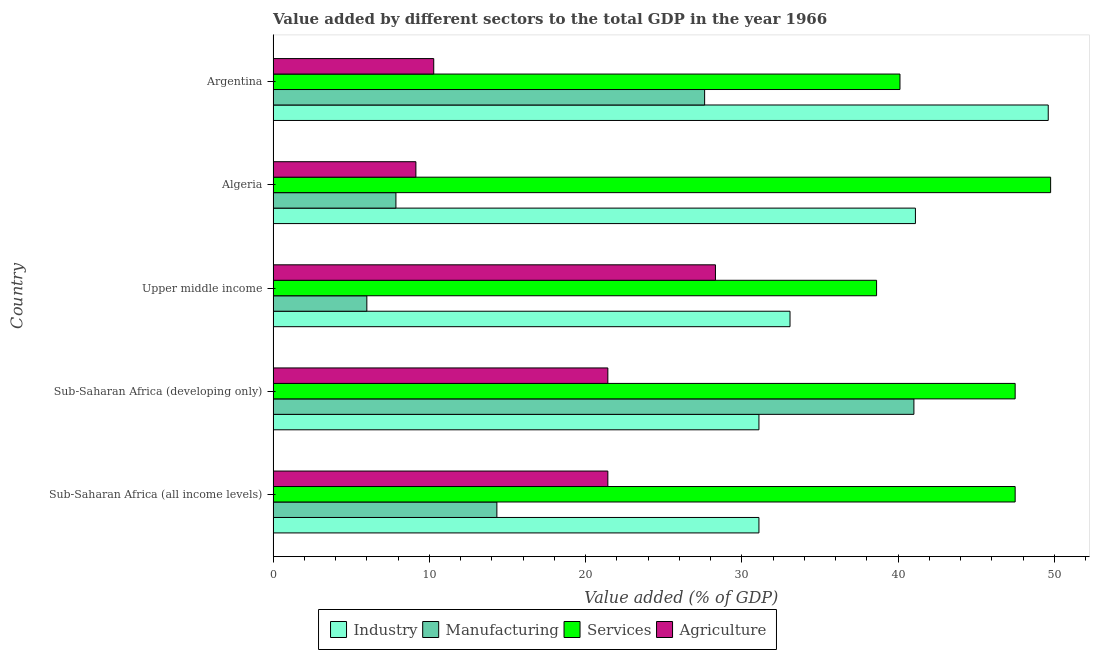How many different coloured bars are there?
Provide a short and direct response. 4. Are the number of bars per tick equal to the number of legend labels?
Ensure brevity in your answer.  Yes. Are the number of bars on each tick of the Y-axis equal?
Your response must be concise. Yes. How many bars are there on the 5th tick from the top?
Give a very brief answer. 4. What is the label of the 5th group of bars from the top?
Keep it short and to the point. Sub-Saharan Africa (all income levels). In how many cases, is the number of bars for a given country not equal to the number of legend labels?
Offer a very short reply. 0. What is the value added by manufacturing sector in Upper middle income?
Provide a short and direct response. 6. Across all countries, what is the maximum value added by industrial sector?
Make the answer very short. 49.6. Across all countries, what is the minimum value added by manufacturing sector?
Give a very brief answer. 6. In which country was the value added by services sector maximum?
Your answer should be compact. Algeria. In which country was the value added by industrial sector minimum?
Make the answer very short. Sub-Saharan Africa (all income levels). What is the total value added by industrial sector in the graph?
Your answer should be compact. 185.97. What is the difference between the value added by manufacturing sector in Algeria and that in Sub-Saharan Africa (all income levels)?
Offer a terse response. -6.46. What is the difference between the value added by services sector in Sub-Saharan Africa (developing only) and the value added by agricultural sector in Algeria?
Offer a terse response. 38.35. What is the average value added by industrial sector per country?
Ensure brevity in your answer.  37.19. What is the difference between the value added by services sector and value added by agricultural sector in Sub-Saharan Africa (all income levels)?
Provide a short and direct response. 26.07. What is the ratio of the value added by agricultural sector in Algeria to that in Argentina?
Your answer should be compact. 0.89. Is the value added by agricultural sector in Sub-Saharan Africa (all income levels) less than that in Sub-Saharan Africa (developing only)?
Your response must be concise. No. Is the difference between the value added by industrial sector in Algeria and Sub-Saharan Africa (developing only) greater than the difference between the value added by services sector in Algeria and Sub-Saharan Africa (developing only)?
Give a very brief answer. Yes. What is the difference between the highest and the second highest value added by industrial sector?
Make the answer very short. 8.5. What is the difference between the highest and the lowest value added by industrial sector?
Your answer should be compact. 18.51. In how many countries, is the value added by industrial sector greater than the average value added by industrial sector taken over all countries?
Your answer should be very brief. 2. Is the sum of the value added by agricultural sector in Algeria and Sub-Saharan Africa (all income levels) greater than the maximum value added by services sector across all countries?
Make the answer very short. No. What does the 4th bar from the top in Algeria represents?
Keep it short and to the point. Industry. What does the 4th bar from the bottom in Algeria represents?
Give a very brief answer. Agriculture. How many countries are there in the graph?
Make the answer very short. 5. Does the graph contain any zero values?
Make the answer very short. No. How are the legend labels stacked?
Offer a terse response. Horizontal. What is the title of the graph?
Provide a short and direct response. Value added by different sectors to the total GDP in the year 1966. What is the label or title of the X-axis?
Make the answer very short. Value added (% of GDP). What is the label or title of the Y-axis?
Ensure brevity in your answer.  Country. What is the Value added (% of GDP) of Industry in Sub-Saharan Africa (all income levels)?
Your answer should be compact. 31.09. What is the Value added (% of GDP) in Manufacturing in Sub-Saharan Africa (all income levels)?
Offer a very short reply. 14.32. What is the Value added (% of GDP) of Services in Sub-Saharan Africa (all income levels)?
Make the answer very short. 47.49. What is the Value added (% of GDP) of Agriculture in Sub-Saharan Africa (all income levels)?
Provide a succinct answer. 21.42. What is the Value added (% of GDP) in Industry in Sub-Saharan Africa (developing only)?
Offer a very short reply. 31.09. What is the Value added (% of GDP) in Manufacturing in Sub-Saharan Africa (developing only)?
Provide a succinct answer. 41.01. What is the Value added (% of GDP) of Services in Sub-Saharan Africa (developing only)?
Provide a short and direct response. 47.49. What is the Value added (% of GDP) of Agriculture in Sub-Saharan Africa (developing only)?
Give a very brief answer. 21.42. What is the Value added (% of GDP) of Industry in Upper middle income?
Make the answer very short. 33.08. What is the Value added (% of GDP) in Manufacturing in Upper middle income?
Ensure brevity in your answer.  6. What is the Value added (% of GDP) of Services in Upper middle income?
Make the answer very short. 38.62. What is the Value added (% of GDP) in Agriculture in Upper middle income?
Give a very brief answer. 28.31. What is the Value added (% of GDP) of Industry in Algeria?
Provide a succinct answer. 41.11. What is the Value added (% of GDP) of Manufacturing in Algeria?
Offer a terse response. 7.86. What is the Value added (% of GDP) in Services in Algeria?
Offer a very short reply. 49.76. What is the Value added (% of GDP) in Agriculture in Algeria?
Provide a succinct answer. 9.14. What is the Value added (% of GDP) in Industry in Argentina?
Keep it short and to the point. 49.6. What is the Value added (% of GDP) of Manufacturing in Argentina?
Provide a succinct answer. 27.62. What is the Value added (% of GDP) in Services in Argentina?
Make the answer very short. 40.12. What is the Value added (% of GDP) of Agriculture in Argentina?
Make the answer very short. 10.28. Across all countries, what is the maximum Value added (% of GDP) of Industry?
Your response must be concise. 49.6. Across all countries, what is the maximum Value added (% of GDP) of Manufacturing?
Make the answer very short. 41.01. Across all countries, what is the maximum Value added (% of GDP) in Services?
Give a very brief answer. 49.76. Across all countries, what is the maximum Value added (% of GDP) of Agriculture?
Provide a short and direct response. 28.31. Across all countries, what is the minimum Value added (% of GDP) in Industry?
Make the answer very short. 31.09. Across all countries, what is the minimum Value added (% of GDP) of Manufacturing?
Provide a succinct answer. 6. Across all countries, what is the minimum Value added (% of GDP) of Services?
Give a very brief answer. 38.62. Across all countries, what is the minimum Value added (% of GDP) of Agriculture?
Give a very brief answer. 9.14. What is the total Value added (% of GDP) in Industry in the graph?
Make the answer very short. 185.97. What is the total Value added (% of GDP) of Manufacturing in the graph?
Offer a very short reply. 96.8. What is the total Value added (% of GDP) of Services in the graph?
Provide a short and direct response. 223.47. What is the total Value added (% of GDP) in Agriculture in the graph?
Keep it short and to the point. 90.57. What is the difference between the Value added (% of GDP) in Industry in Sub-Saharan Africa (all income levels) and that in Sub-Saharan Africa (developing only)?
Provide a succinct answer. 0. What is the difference between the Value added (% of GDP) of Manufacturing in Sub-Saharan Africa (all income levels) and that in Sub-Saharan Africa (developing only)?
Keep it short and to the point. -26.69. What is the difference between the Value added (% of GDP) in Agriculture in Sub-Saharan Africa (all income levels) and that in Sub-Saharan Africa (developing only)?
Offer a very short reply. 0. What is the difference between the Value added (% of GDP) of Industry in Sub-Saharan Africa (all income levels) and that in Upper middle income?
Give a very brief answer. -1.99. What is the difference between the Value added (% of GDP) in Manufacturing in Sub-Saharan Africa (all income levels) and that in Upper middle income?
Make the answer very short. 8.32. What is the difference between the Value added (% of GDP) in Services in Sub-Saharan Africa (all income levels) and that in Upper middle income?
Keep it short and to the point. 8.87. What is the difference between the Value added (% of GDP) in Agriculture in Sub-Saharan Africa (all income levels) and that in Upper middle income?
Make the answer very short. -6.89. What is the difference between the Value added (% of GDP) of Industry in Sub-Saharan Africa (all income levels) and that in Algeria?
Provide a short and direct response. -10.01. What is the difference between the Value added (% of GDP) of Manufacturing in Sub-Saharan Africa (all income levels) and that in Algeria?
Make the answer very short. 6.46. What is the difference between the Value added (% of GDP) of Services in Sub-Saharan Africa (all income levels) and that in Algeria?
Provide a short and direct response. -2.27. What is the difference between the Value added (% of GDP) in Agriculture in Sub-Saharan Africa (all income levels) and that in Algeria?
Provide a succinct answer. 12.28. What is the difference between the Value added (% of GDP) of Industry in Sub-Saharan Africa (all income levels) and that in Argentina?
Keep it short and to the point. -18.51. What is the difference between the Value added (% of GDP) in Manufacturing in Sub-Saharan Africa (all income levels) and that in Argentina?
Your answer should be compact. -13.3. What is the difference between the Value added (% of GDP) in Services in Sub-Saharan Africa (all income levels) and that in Argentina?
Give a very brief answer. 7.37. What is the difference between the Value added (% of GDP) of Agriculture in Sub-Saharan Africa (all income levels) and that in Argentina?
Offer a very short reply. 11.14. What is the difference between the Value added (% of GDP) in Industry in Sub-Saharan Africa (developing only) and that in Upper middle income?
Ensure brevity in your answer.  -1.99. What is the difference between the Value added (% of GDP) in Manufacturing in Sub-Saharan Africa (developing only) and that in Upper middle income?
Offer a terse response. 35.01. What is the difference between the Value added (% of GDP) in Services in Sub-Saharan Africa (developing only) and that in Upper middle income?
Your response must be concise. 8.87. What is the difference between the Value added (% of GDP) of Agriculture in Sub-Saharan Africa (developing only) and that in Upper middle income?
Offer a very short reply. -6.89. What is the difference between the Value added (% of GDP) of Industry in Sub-Saharan Africa (developing only) and that in Algeria?
Provide a succinct answer. -10.01. What is the difference between the Value added (% of GDP) in Manufacturing in Sub-Saharan Africa (developing only) and that in Algeria?
Your answer should be compact. 33.15. What is the difference between the Value added (% of GDP) of Services in Sub-Saharan Africa (developing only) and that in Algeria?
Your answer should be compact. -2.27. What is the difference between the Value added (% of GDP) in Agriculture in Sub-Saharan Africa (developing only) and that in Algeria?
Your answer should be compact. 12.28. What is the difference between the Value added (% of GDP) in Industry in Sub-Saharan Africa (developing only) and that in Argentina?
Keep it short and to the point. -18.51. What is the difference between the Value added (% of GDP) in Manufacturing in Sub-Saharan Africa (developing only) and that in Argentina?
Your answer should be compact. 13.39. What is the difference between the Value added (% of GDP) in Services in Sub-Saharan Africa (developing only) and that in Argentina?
Offer a very short reply. 7.37. What is the difference between the Value added (% of GDP) in Agriculture in Sub-Saharan Africa (developing only) and that in Argentina?
Offer a terse response. 11.14. What is the difference between the Value added (% of GDP) of Industry in Upper middle income and that in Algeria?
Keep it short and to the point. -8.03. What is the difference between the Value added (% of GDP) of Manufacturing in Upper middle income and that in Algeria?
Keep it short and to the point. -1.86. What is the difference between the Value added (% of GDP) of Services in Upper middle income and that in Algeria?
Ensure brevity in your answer.  -11.14. What is the difference between the Value added (% of GDP) of Agriculture in Upper middle income and that in Algeria?
Offer a very short reply. 19.17. What is the difference between the Value added (% of GDP) in Industry in Upper middle income and that in Argentina?
Provide a short and direct response. -16.53. What is the difference between the Value added (% of GDP) in Manufacturing in Upper middle income and that in Argentina?
Your response must be concise. -21.62. What is the difference between the Value added (% of GDP) in Services in Upper middle income and that in Argentina?
Your answer should be very brief. -1.5. What is the difference between the Value added (% of GDP) of Agriculture in Upper middle income and that in Argentina?
Offer a very short reply. 18.03. What is the difference between the Value added (% of GDP) in Industry in Algeria and that in Argentina?
Your response must be concise. -8.5. What is the difference between the Value added (% of GDP) in Manufacturing in Algeria and that in Argentina?
Provide a succinct answer. -19.76. What is the difference between the Value added (% of GDP) of Services in Algeria and that in Argentina?
Give a very brief answer. 9.64. What is the difference between the Value added (% of GDP) of Agriculture in Algeria and that in Argentina?
Your response must be concise. -1.14. What is the difference between the Value added (% of GDP) of Industry in Sub-Saharan Africa (all income levels) and the Value added (% of GDP) of Manufacturing in Sub-Saharan Africa (developing only)?
Ensure brevity in your answer.  -9.92. What is the difference between the Value added (% of GDP) in Industry in Sub-Saharan Africa (all income levels) and the Value added (% of GDP) in Services in Sub-Saharan Africa (developing only)?
Provide a short and direct response. -16.4. What is the difference between the Value added (% of GDP) in Industry in Sub-Saharan Africa (all income levels) and the Value added (% of GDP) in Agriculture in Sub-Saharan Africa (developing only)?
Provide a succinct answer. 9.67. What is the difference between the Value added (% of GDP) in Manufacturing in Sub-Saharan Africa (all income levels) and the Value added (% of GDP) in Services in Sub-Saharan Africa (developing only)?
Offer a very short reply. -33.17. What is the difference between the Value added (% of GDP) of Manufacturing in Sub-Saharan Africa (all income levels) and the Value added (% of GDP) of Agriculture in Sub-Saharan Africa (developing only)?
Your answer should be very brief. -7.1. What is the difference between the Value added (% of GDP) of Services in Sub-Saharan Africa (all income levels) and the Value added (% of GDP) of Agriculture in Sub-Saharan Africa (developing only)?
Your answer should be compact. 26.07. What is the difference between the Value added (% of GDP) of Industry in Sub-Saharan Africa (all income levels) and the Value added (% of GDP) of Manufacturing in Upper middle income?
Offer a very short reply. 25.09. What is the difference between the Value added (% of GDP) in Industry in Sub-Saharan Africa (all income levels) and the Value added (% of GDP) in Services in Upper middle income?
Give a very brief answer. -7.53. What is the difference between the Value added (% of GDP) of Industry in Sub-Saharan Africa (all income levels) and the Value added (% of GDP) of Agriculture in Upper middle income?
Your response must be concise. 2.78. What is the difference between the Value added (% of GDP) in Manufacturing in Sub-Saharan Africa (all income levels) and the Value added (% of GDP) in Services in Upper middle income?
Offer a very short reply. -24.3. What is the difference between the Value added (% of GDP) in Manufacturing in Sub-Saharan Africa (all income levels) and the Value added (% of GDP) in Agriculture in Upper middle income?
Offer a very short reply. -13.99. What is the difference between the Value added (% of GDP) in Services in Sub-Saharan Africa (all income levels) and the Value added (% of GDP) in Agriculture in Upper middle income?
Offer a very short reply. 19.18. What is the difference between the Value added (% of GDP) in Industry in Sub-Saharan Africa (all income levels) and the Value added (% of GDP) in Manufacturing in Algeria?
Offer a very short reply. 23.23. What is the difference between the Value added (% of GDP) in Industry in Sub-Saharan Africa (all income levels) and the Value added (% of GDP) in Services in Algeria?
Your response must be concise. -18.67. What is the difference between the Value added (% of GDP) in Industry in Sub-Saharan Africa (all income levels) and the Value added (% of GDP) in Agriculture in Algeria?
Give a very brief answer. 21.95. What is the difference between the Value added (% of GDP) in Manufacturing in Sub-Saharan Africa (all income levels) and the Value added (% of GDP) in Services in Algeria?
Give a very brief answer. -35.44. What is the difference between the Value added (% of GDP) in Manufacturing in Sub-Saharan Africa (all income levels) and the Value added (% of GDP) in Agriculture in Algeria?
Provide a succinct answer. 5.18. What is the difference between the Value added (% of GDP) of Services in Sub-Saharan Africa (all income levels) and the Value added (% of GDP) of Agriculture in Algeria?
Provide a short and direct response. 38.35. What is the difference between the Value added (% of GDP) in Industry in Sub-Saharan Africa (all income levels) and the Value added (% of GDP) in Manufacturing in Argentina?
Your response must be concise. 3.48. What is the difference between the Value added (% of GDP) of Industry in Sub-Saharan Africa (all income levels) and the Value added (% of GDP) of Services in Argentina?
Offer a very short reply. -9.03. What is the difference between the Value added (% of GDP) in Industry in Sub-Saharan Africa (all income levels) and the Value added (% of GDP) in Agriculture in Argentina?
Provide a succinct answer. 20.81. What is the difference between the Value added (% of GDP) of Manufacturing in Sub-Saharan Africa (all income levels) and the Value added (% of GDP) of Services in Argentina?
Offer a terse response. -25.8. What is the difference between the Value added (% of GDP) in Manufacturing in Sub-Saharan Africa (all income levels) and the Value added (% of GDP) in Agriculture in Argentina?
Your answer should be compact. 4.04. What is the difference between the Value added (% of GDP) in Services in Sub-Saharan Africa (all income levels) and the Value added (% of GDP) in Agriculture in Argentina?
Your response must be concise. 37.21. What is the difference between the Value added (% of GDP) of Industry in Sub-Saharan Africa (developing only) and the Value added (% of GDP) of Manufacturing in Upper middle income?
Ensure brevity in your answer.  25.09. What is the difference between the Value added (% of GDP) of Industry in Sub-Saharan Africa (developing only) and the Value added (% of GDP) of Services in Upper middle income?
Your answer should be very brief. -7.53. What is the difference between the Value added (% of GDP) in Industry in Sub-Saharan Africa (developing only) and the Value added (% of GDP) in Agriculture in Upper middle income?
Offer a terse response. 2.78. What is the difference between the Value added (% of GDP) of Manufacturing in Sub-Saharan Africa (developing only) and the Value added (% of GDP) of Services in Upper middle income?
Provide a short and direct response. 2.39. What is the difference between the Value added (% of GDP) of Manufacturing in Sub-Saharan Africa (developing only) and the Value added (% of GDP) of Agriculture in Upper middle income?
Your answer should be very brief. 12.7. What is the difference between the Value added (% of GDP) of Services in Sub-Saharan Africa (developing only) and the Value added (% of GDP) of Agriculture in Upper middle income?
Provide a short and direct response. 19.18. What is the difference between the Value added (% of GDP) of Industry in Sub-Saharan Africa (developing only) and the Value added (% of GDP) of Manufacturing in Algeria?
Your answer should be very brief. 23.23. What is the difference between the Value added (% of GDP) in Industry in Sub-Saharan Africa (developing only) and the Value added (% of GDP) in Services in Algeria?
Make the answer very short. -18.67. What is the difference between the Value added (% of GDP) in Industry in Sub-Saharan Africa (developing only) and the Value added (% of GDP) in Agriculture in Algeria?
Give a very brief answer. 21.95. What is the difference between the Value added (% of GDP) of Manufacturing in Sub-Saharan Africa (developing only) and the Value added (% of GDP) of Services in Algeria?
Provide a succinct answer. -8.75. What is the difference between the Value added (% of GDP) in Manufacturing in Sub-Saharan Africa (developing only) and the Value added (% of GDP) in Agriculture in Algeria?
Your answer should be very brief. 31.87. What is the difference between the Value added (% of GDP) of Services in Sub-Saharan Africa (developing only) and the Value added (% of GDP) of Agriculture in Algeria?
Offer a terse response. 38.35. What is the difference between the Value added (% of GDP) in Industry in Sub-Saharan Africa (developing only) and the Value added (% of GDP) in Manufacturing in Argentina?
Ensure brevity in your answer.  3.48. What is the difference between the Value added (% of GDP) in Industry in Sub-Saharan Africa (developing only) and the Value added (% of GDP) in Services in Argentina?
Give a very brief answer. -9.03. What is the difference between the Value added (% of GDP) in Industry in Sub-Saharan Africa (developing only) and the Value added (% of GDP) in Agriculture in Argentina?
Offer a terse response. 20.81. What is the difference between the Value added (% of GDP) in Manufacturing in Sub-Saharan Africa (developing only) and the Value added (% of GDP) in Services in Argentina?
Provide a short and direct response. 0.89. What is the difference between the Value added (% of GDP) of Manufacturing in Sub-Saharan Africa (developing only) and the Value added (% of GDP) of Agriculture in Argentina?
Your answer should be compact. 30.73. What is the difference between the Value added (% of GDP) in Services in Sub-Saharan Africa (developing only) and the Value added (% of GDP) in Agriculture in Argentina?
Provide a short and direct response. 37.21. What is the difference between the Value added (% of GDP) of Industry in Upper middle income and the Value added (% of GDP) of Manufacturing in Algeria?
Provide a short and direct response. 25.22. What is the difference between the Value added (% of GDP) of Industry in Upper middle income and the Value added (% of GDP) of Services in Algeria?
Your answer should be very brief. -16.68. What is the difference between the Value added (% of GDP) of Industry in Upper middle income and the Value added (% of GDP) of Agriculture in Algeria?
Provide a short and direct response. 23.94. What is the difference between the Value added (% of GDP) in Manufacturing in Upper middle income and the Value added (% of GDP) in Services in Algeria?
Offer a terse response. -43.76. What is the difference between the Value added (% of GDP) of Manufacturing in Upper middle income and the Value added (% of GDP) of Agriculture in Algeria?
Ensure brevity in your answer.  -3.14. What is the difference between the Value added (% of GDP) in Services in Upper middle income and the Value added (% of GDP) in Agriculture in Algeria?
Ensure brevity in your answer.  29.48. What is the difference between the Value added (% of GDP) of Industry in Upper middle income and the Value added (% of GDP) of Manufacturing in Argentina?
Your response must be concise. 5.46. What is the difference between the Value added (% of GDP) of Industry in Upper middle income and the Value added (% of GDP) of Services in Argentina?
Provide a short and direct response. -7.04. What is the difference between the Value added (% of GDP) of Industry in Upper middle income and the Value added (% of GDP) of Agriculture in Argentina?
Your answer should be compact. 22.8. What is the difference between the Value added (% of GDP) in Manufacturing in Upper middle income and the Value added (% of GDP) in Services in Argentina?
Give a very brief answer. -34.12. What is the difference between the Value added (% of GDP) of Manufacturing in Upper middle income and the Value added (% of GDP) of Agriculture in Argentina?
Offer a very short reply. -4.28. What is the difference between the Value added (% of GDP) in Services in Upper middle income and the Value added (% of GDP) in Agriculture in Argentina?
Provide a short and direct response. 28.34. What is the difference between the Value added (% of GDP) in Industry in Algeria and the Value added (% of GDP) in Manufacturing in Argentina?
Offer a very short reply. 13.49. What is the difference between the Value added (% of GDP) in Industry in Algeria and the Value added (% of GDP) in Services in Argentina?
Give a very brief answer. 0.99. What is the difference between the Value added (% of GDP) in Industry in Algeria and the Value added (% of GDP) in Agriculture in Argentina?
Your answer should be very brief. 30.83. What is the difference between the Value added (% of GDP) in Manufacturing in Algeria and the Value added (% of GDP) in Services in Argentina?
Your answer should be very brief. -32.26. What is the difference between the Value added (% of GDP) in Manufacturing in Algeria and the Value added (% of GDP) in Agriculture in Argentina?
Offer a very short reply. -2.42. What is the difference between the Value added (% of GDP) in Services in Algeria and the Value added (% of GDP) in Agriculture in Argentina?
Offer a terse response. 39.48. What is the average Value added (% of GDP) of Industry per country?
Your answer should be very brief. 37.19. What is the average Value added (% of GDP) of Manufacturing per country?
Your answer should be very brief. 19.36. What is the average Value added (% of GDP) of Services per country?
Provide a short and direct response. 44.69. What is the average Value added (% of GDP) of Agriculture per country?
Provide a succinct answer. 18.11. What is the difference between the Value added (% of GDP) of Industry and Value added (% of GDP) of Manufacturing in Sub-Saharan Africa (all income levels)?
Offer a terse response. 16.77. What is the difference between the Value added (% of GDP) of Industry and Value added (% of GDP) of Services in Sub-Saharan Africa (all income levels)?
Offer a very short reply. -16.4. What is the difference between the Value added (% of GDP) in Industry and Value added (% of GDP) in Agriculture in Sub-Saharan Africa (all income levels)?
Ensure brevity in your answer.  9.67. What is the difference between the Value added (% of GDP) of Manufacturing and Value added (% of GDP) of Services in Sub-Saharan Africa (all income levels)?
Provide a succinct answer. -33.17. What is the difference between the Value added (% of GDP) in Manufacturing and Value added (% of GDP) in Agriculture in Sub-Saharan Africa (all income levels)?
Give a very brief answer. -7.1. What is the difference between the Value added (% of GDP) in Services and Value added (% of GDP) in Agriculture in Sub-Saharan Africa (all income levels)?
Your answer should be compact. 26.07. What is the difference between the Value added (% of GDP) of Industry and Value added (% of GDP) of Manufacturing in Sub-Saharan Africa (developing only)?
Keep it short and to the point. -9.92. What is the difference between the Value added (% of GDP) in Industry and Value added (% of GDP) in Services in Sub-Saharan Africa (developing only)?
Offer a terse response. -16.4. What is the difference between the Value added (% of GDP) of Industry and Value added (% of GDP) of Agriculture in Sub-Saharan Africa (developing only)?
Your answer should be compact. 9.67. What is the difference between the Value added (% of GDP) in Manufacturing and Value added (% of GDP) in Services in Sub-Saharan Africa (developing only)?
Ensure brevity in your answer.  -6.48. What is the difference between the Value added (% of GDP) of Manufacturing and Value added (% of GDP) of Agriculture in Sub-Saharan Africa (developing only)?
Provide a short and direct response. 19.59. What is the difference between the Value added (% of GDP) of Services and Value added (% of GDP) of Agriculture in Sub-Saharan Africa (developing only)?
Offer a terse response. 26.07. What is the difference between the Value added (% of GDP) in Industry and Value added (% of GDP) in Manufacturing in Upper middle income?
Your answer should be very brief. 27.08. What is the difference between the Value added (% of GDP) of Industry and Value added (% of GDP) of Services in Upper middle income?
Offer a very short reply. -5.54. What is the difference between the Value added (% of GDP) in Industry and Value added (% of GDP) in Agriculture in Upper middle income?
Provide a succinct answer. 4.77. What is the difference between the Value added (% of GDP) of Manufacturing and Value added (% of GDP) of Services in Upper middle income?
Offer a very short reply. -32.62. What is the difference between the Value added (% of GDP) in Manufacturing and Value added (% of GDP) in Agriculture in Upper middle income?
Offer a very short reply. -22.31. What is the difference between the Value added (% of GDP) of Services and Value added (% of GDP) of Agriculture in Upper middle income?
Provide a succinct answer. 10.31. What is the difference between the Value added (% of GDP) in Industry and Value added (% of GDP) in Manufacturing in Algeria?
Keep it short and to the point. 33.25. What is the difference between the Value added (% of GDP) in Industry and Value added (% of GDP) in Services in Algeria?
Keep it short and to the point. -8.65. What is the difference between the Value added (% of GDP) of Industry and Value added (% of GDP) of Agriculture in Algeria?
Offer a very short reply. 31.97. What is the difference between the Value added (% of GDP) in Manufacturing and Value added (% of GDP) in Services in Algeria?
Offer a very short reply. -41.9. What is the difference between the Value added (% of GDP) in Manufacturing and Value added (% of GDP) in Agriculture in Algeria?
Offer a terse response. -1.28. What is the difference between the Value added (% of GDP) of Services and Value added (% of GDP) of Agriculture in Algeria?
Offer a very short reply. 40.62. What is the difference between the Value added (% of GDP) of Industry and Value added (% of GDP) of Manufacturing in Argentina?
Provide a succinct answer. 21.99. What is the difference between the Value added (% of GDP) in Industry and Value added (% of GDP) in Services in Argentina?
Provide a short and direct response. 9.49. What is the difference between the Value added (% of GDP) of Industry and Value added (% of GDP) of Agriculture in Argentina?
Make the answer very short. 39.33. What is the difference between the Value added (% of GDP) of Manufacturing and Value added (% of GDP) of Services in Argentina?
Your answer should be very brief. -12.5. What is the difference between the Value added (% of GDP) of Manufacturing and Value added (% of GDP) of Agriculture in Argentina?
Keep it short and to the point. 17.34. What is the difference between the Value added (% of GDP) in Services and Value added (% of GDP) in Agriculture in Argentina?
Provide a succinct answer. 29.84. What is the ratio of the Value added (% of GDP) of Manufacturing in Sub-Saharan Africa (all income levels) to that in Sub-Saharan Africa (developing only)?
Provide a short and direct response. 0.35. What is the ratio of the Value added (% of GDP) of Services in Sub-Saharan Africa (all income levels) to that in Sub-Saharan Africa (developing only)?
Your answer should be compact. 1. What is the ratio of the Value added (% of GDP) of Agriculture in Sub-Saharan Africa (all income levels) to that in Sub-Saharan Africa (developing only)?
Give a very brief answer. 1. What is the ratio of the Value added (% of GDP) in Industry in Sub-Saharan Africa (all income levels) to that in Upper middle income?
Offer a very short reply. 0.94. What is the ratio of the Value added (% of GDP) of Manufacturing in Sub-Saharan Africa (all income levels) to that in Upper middle income?
Offer a very short reply. 2.39. What is the ratio of the Value added (% of GDP) in Services in Sub-Saharan Africa (all income levels) to that in Upper middle income?
Your response must be concise. 1.23. What is the ratio of the Value added (% of GDP) of Agriculture in Sub-Saharan Africa (all income levels) to that in Upper middle income?
Ensure brevity in your answer.  0.76. What is the ratio of the Value added (% of GDP) of Industry in Sub-Saharan Africa (all income levels) to that in Algeria?
Your answer should be compact. 0.76. What is the ratio of the Value added (% of GDP) of Manufacturing in Sub-Saharan Africa (all income levels) to that in Algeria?
Make the answer very short. 1.82. What is the ratio of the Value added (% of GDP) of Services in Sub-Saharan Africa (all income levels) to that in Algeria?
Ensure brevity in your answer.  0.95. What is the ratio of the Value added (% of GDP) of Agriculture in Sub-Saharan Africa (all income levels) to that in Algeria?
Your answer should be compact. 2.34. What is the ratio of the Value added (% of GDP) of Industry in Sub-Saharan Africa (all income levels) to that in Argentina?
Keep it short and to the point. 0.63. What is the ratio of the Value added (% of GDP) in Manufacturing in Sub-Saharan Africa (all income levels) to that in Argentina?
Keep it short and to the point. 0.52. What is the ratio of the Value added (% of GDP) of Services in Sub-Saharan Africa (all income levels) to that in Argentina?
Keep it short and to the point. 1.18. What is the ratio of the Value added (% of GDP) in Agriculture in Sub-Saharan Africa (all income levels) to that in Argentina?
Give a very brief answer. 2.08. What is the ratio of the Value added (% of GDP) of Industry in Sub-Saharan Africa (developing only) to that in Upper middle income?
Your response must be concise. 0.94. What is the ratio of the Value added (% of GDP) in Manufacturing in Sub-Saharan Africa (developing only) to that in Upper middle income?
Your response must be concise. 6.84. What is the ratio of the Value added (% of GDP) in Services in Sub-Saharan Africa (developing only) to that in Upper middle income?
Offer a very short reply. 1.23. What is the ratio of the Value added (% of GDP) in Agriculture in Sub-Saharan Africa (developing only) to that in Upper middle income?
Provide a short and direct response. 0.76. What is the ratio of the Value added (% of GDP) of Industry in Sub-Saharan Africa (developing only) to that in Algeria?
Make the answer very short. 0.76. What is the ratio of the Value added (% of GDP) in Manufacturing in Sub-Saharan Africa (developing only) to that in Algeria?
Your answer should be very brief. 5.22. What is the ratio of the Value added (% of GDP) in Services in Sub-Saharan Africa (developing only) to that in Algeria?
Provide a succinct answer. 0.95. What is the ratio of the Value added (% of GDP) of Agriculture in Sub-Saharan Africa (developing only) to that in Algeria?
Offer a terse response. 2.34. What is the ratio of the Value added (% of GDP) in Industry in Sub-Saharan Africa (developing only) to that in Argentina?
Make the answer very short. 0.63. What is the ratio of the Value added (% of GDP) in Manufacturing in Sub-Saharan Africa (developing only) to that in Argentina?
Your answer should be compact. 1.49. What is the ratio of the Value added (% of GDP) of Services in Sub-Saharan Africa (developing only) to that in Argentina?
Make the answer very short. 1.18. What is the ratio of the Value added (% of GDP) of Agriculture in Sub-Saharan Africa (developing only) to that in Argentina?
Your answer should be very brief. 2.08. What is the ratio of the Value added (% of GDP) in Industry in Upper middle income to that in Algeria?
Ensure brevity in your answer.  0.8. What is the ratio of the Value added (% of GDP) of Manufacturing in Upper middle income to that in Algeria?
Keep it short and to the point. 0.76. What is the ratio of the Value added (% of GDP) of Services in Upper middle income to that in Algeria?
Your answer should be very brief. 0.78. What is the ratio of the Value added (% of GDP) of Agriculture in Upper middle income to that in Algeria?
Your answer should be compact. 3.1. What is the ratio of the Value added (% of GDP) of Industry in Upper middle income to that in Argentina?
Provide a succinct answer. 0.67. What is the ratio of the Value added (% of GDP) in Manufacturing in Upper middle income to that in Argentina?
Provide a succinct answer. 0.22. What is the ratio of the Value added (% of GDP) of Services in Upper middle income to that in Argentina?
Keep it short and to the point. 0.96. What is the ratio of the Value added (% of GDP) of Agriculture in Upper middle income to that in Argentina?
Give a very brief answer. 2.75. What is the ratio of the Value added (% of GDP) of Industry in Algeria to that in Argentina?
Your answer should be very brief. 0.83. What is the ratio of the Value added (% of GDP) of Manufacturing in Algeria to that in Argentina?
Provide a succinct answer. 0.28. What is the ratio of the Value added (% of GDP) in Services in Algeria to that in Argentina?
Ensure brevity in your answer.  1.24. What is the ratio of the Value added (% of GDP) of Agriculture in Algeria to that in Argentina?
Provide a succinct answer. 0.89. What is the difference between the highest and the second highest Value added (% of GDP) of Industry?
Make the answer very short. 8.5. What is the difference between the highest and the second highest Value added (% of GDP) in Manufacturing?
Keep it short and to the point. 13.39. What is the difference between the highest and the second highest Value added (% of GDP) in Services?
Ensure brevity in your answer.  2.27. What is the difference between the highest and the second highest Value added (% of GDP) in Agriculture?
Give a very brief answer. 6.89. What is the difference between the highest and the lowest Value added (% of GDP) of Industry?
Your answer should be compact. 18.51. What is the difference between the highest and the lowest Value added (% of GDP) in Manufacturing?
Ensure brevity in your answer.  35.01. What is the difference between the highest and the lowest Value added (% of GDP) of Services?
Your answer should be very brief. 11.14. What is the difference between the highest and the lowest Value added (% of GDP) of Agriculture?
Ensure brevity in your answer.  19.17. 